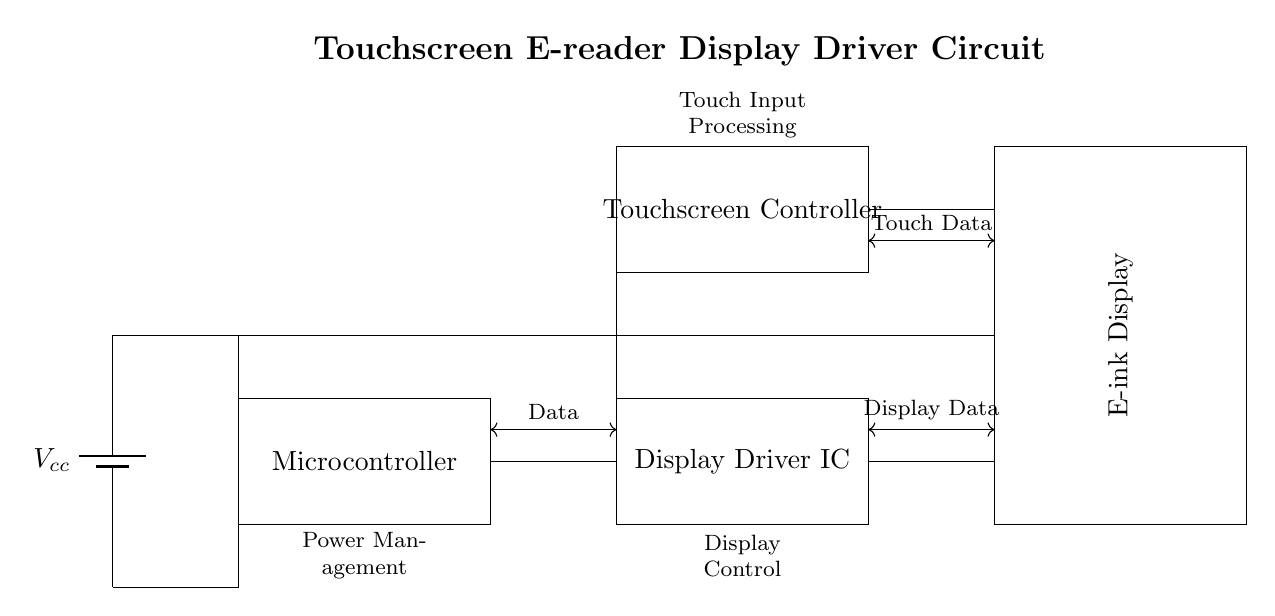What components are present in the circuit? The components in the circuit include a battery, microcontroller, display driver IC, touchscreen controller, and an e-ink display. These are identified visually in the diagram by their labeled rectangles.
Answer: battery, microcontroller, display driver IC, touchscreen controller, e-ink display What is the function of the microcontroller? The microcontroller controls the data flow and processing tasks within the circuit, functioning as the brain of the e-reader device. This role is indicated by its position and labeling in the diagram.
Answer: data control What is the purpose of the touchscreen controller? The touchscreen controller processes touch input, allowing the user to interact with the e-reader's display. It is located above the display driver IC in the diagram and marked with the relevant label.
Answer: touch input processing How many types of data connections are there in the circuit? There are three types of data connections: data, display data, and touch data. Each type is represented by bidirectional arrows connecting specific components in the diagram, indicating communication paths.
Answer: three What role does the display driver IC play relative to the e-ink display? The display driver IC is responsible for sending display data to the e-ink display, which translates the digital signals into visual output. This connection is illustrated in the diagram with a data line labeled as "Display Data."
Answer: driving display What is the voltage provided by the power supply? The voltage provided by the power supply is denoted as Vcc. Although the exact value is not specified in the diagram, it represents the supply voltage for the circuit components, typically a common voltage level for such devices.
Answer: Vcc What is the significance of the power management label in the circuit? The power management label indicates the part of the circuit that deals with distributing and managing power to various components, ensuring they receive the proper voltage and current. This is vital for the circuit's operation and is represented in the diagram under the power supply section.
Answer: power distribution 